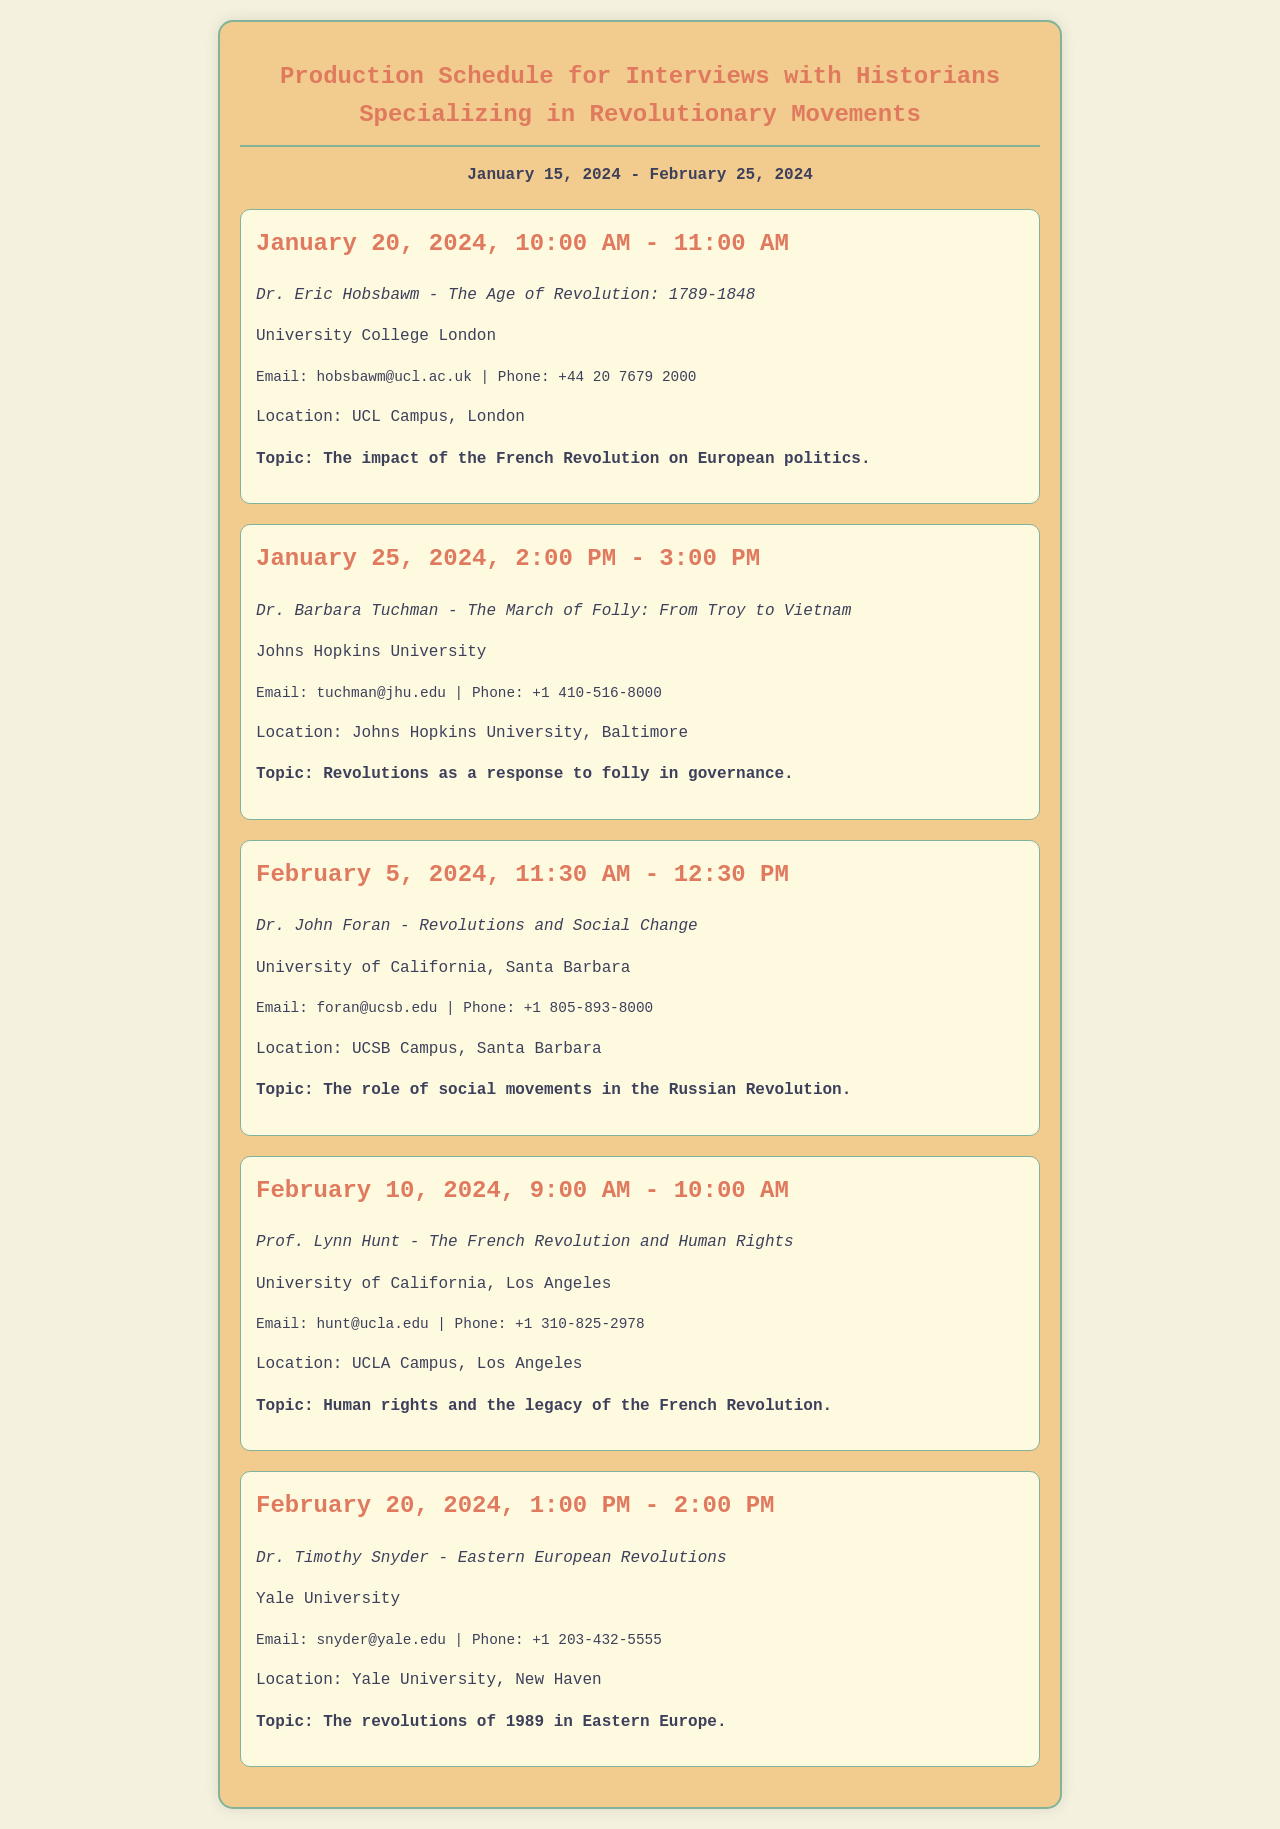what date is the first interview scheduled? The first interview is scheduled on January 20, 2024.
Answer: January 20, 2024 who is the historian interviewed on January 25, 2024? The historian interviewed on January 25, 2024, is Dr. Barbara Tuchman.
Answer: Dr. Barbara Tuchman what is the topic of the interview on February 10, 2024? The topic of the interview on February 10, 2024, is "Human rights and the legacy of the French Revolution."
Answer: Human rights and the legacy of the French Revolution how many interviews are scheduled in total? The schedule lists a total of five interviews.
Answer: five which university is Dr. Timothy Snyder affiliated with? Dr. Timothy Snyder is affiliated with Yale University.
Answer: Yale University what time does the interview with Dr. John Foran take place? The interview with Dr. John Foran takes place from 11:30 AM to 12:30 PM.
Answer: 11:30 AM - 12:30 PM which historian's work focuses on Eastern European revolutions? Dr. Timothy Snyder's work focuses on Eastern European revolutions.
Answer: Dr. Timothy Snyder how long is each interview scheduled to last? Each interview is scheduled to last one hour.
Answer: one hour where is the interview with Prof. Lynn Hunt located? The interview with Prof. Lynn Hunt is located at UCLA Campus, Los Angeles.
Answer: UCLA Campus, Los Angeles 